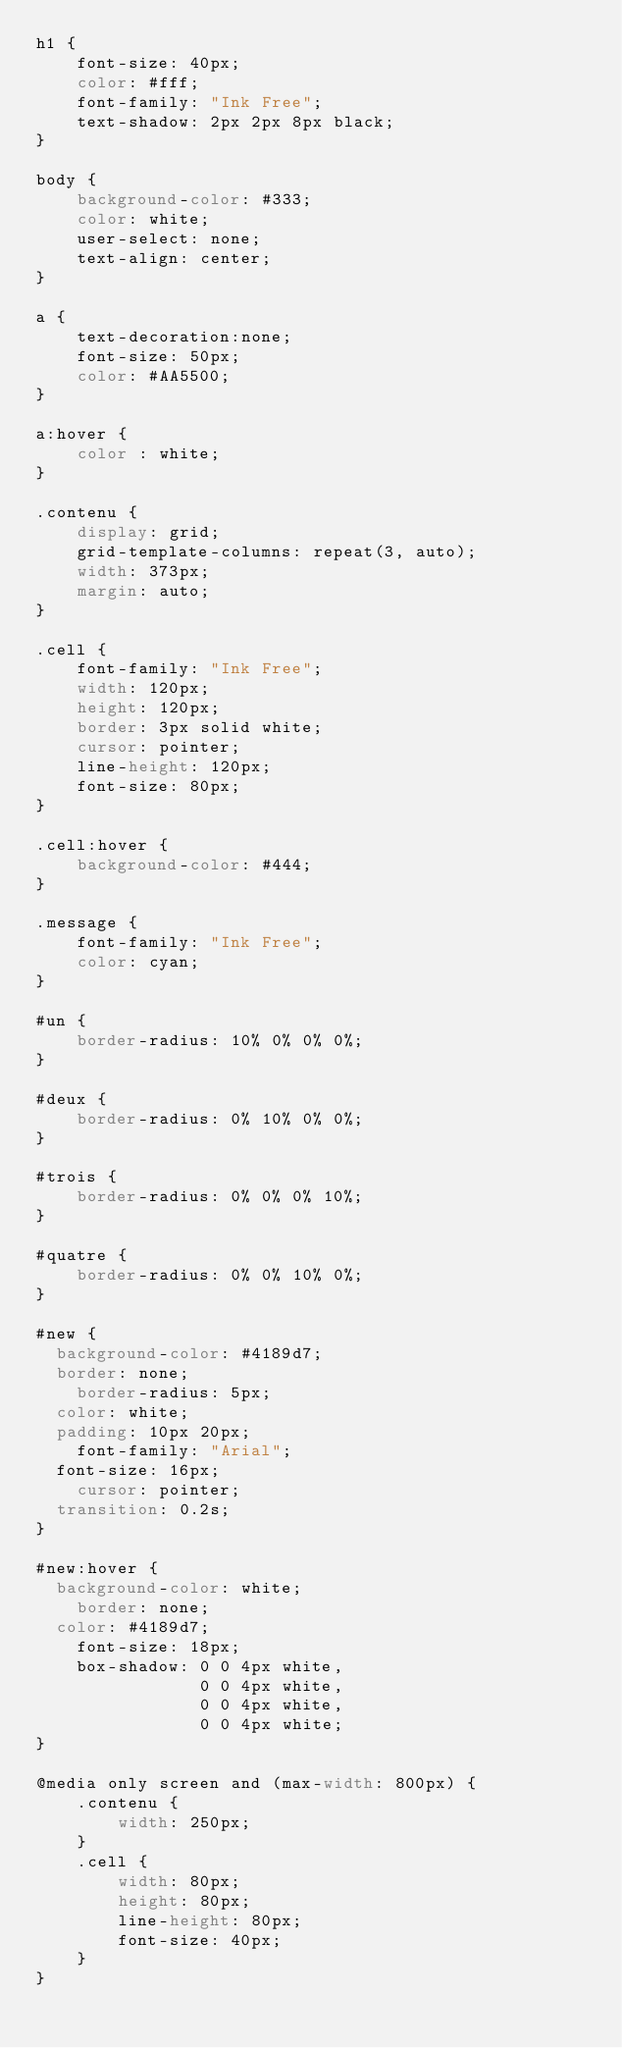<code> <loc_0><loc_0><loc_500><loc_500><_CSS_>h1 {
    font-size: 40px;
    color: #fff;
    font-family: "Ink Free";
    text-shadow: 2px 2px 8px black;
}

body {
    background-color: #333;
    color: white;
    user-select: none;
    text-align: center;
}

a {
    text-decoration:none;
    font-size: 50px;
    color: #AA5500;
}

a:hover {
    color : white;
}

.contenu {
    display: grid;
    grid-template-columns: repeat(3, auto);
    width: 373px;
    margin: auto;
}

.cell {
    font-family: "Ink Free";
    width: 120px;
    height: 120px;
    border: 3px solid white;
    cursor: pointer;
    line-height: 120px;
    font-size: 80px;
}

.cell:hover {
    background-color: #444;
}

.message {
    font-family: "Ink Free";
    color: cyan;
}

#un {
    border-radius: 10% 0% 0% 0%;
}

#deux {
    border-radius: 0% 10% 0% 0%;
}

#trois {
    border-radius: 0% 0% 0% 10%;
}

#quatre {
    border-radius: 0% 0% 10% 0%;
}

#new {
	background-color: #4189d7;
	border: none;
    border-radius: 5px;
	color: white;
	padding: 10px 20px;
    font-family: "Arial";
	font-size: 16px;
    cursor: pointer;
	transition: 0.2s;
}

#new:hover {
	background-color: white;
    border: none;
	color: #4189d7;
    font-size: 18px;
    box-shadow: 0 0 4px white,
                0 0 4px white,
                0 0 4px white,
                0 0 4px white;
}

@media only screen and (max-width: 800px) {
    .contenu {
        width: 250px;
    }
    .cell {
        width: 80px;
        height: 80px;
        line-height: 80px;
        font-size: 40px;
    }
}</code> 